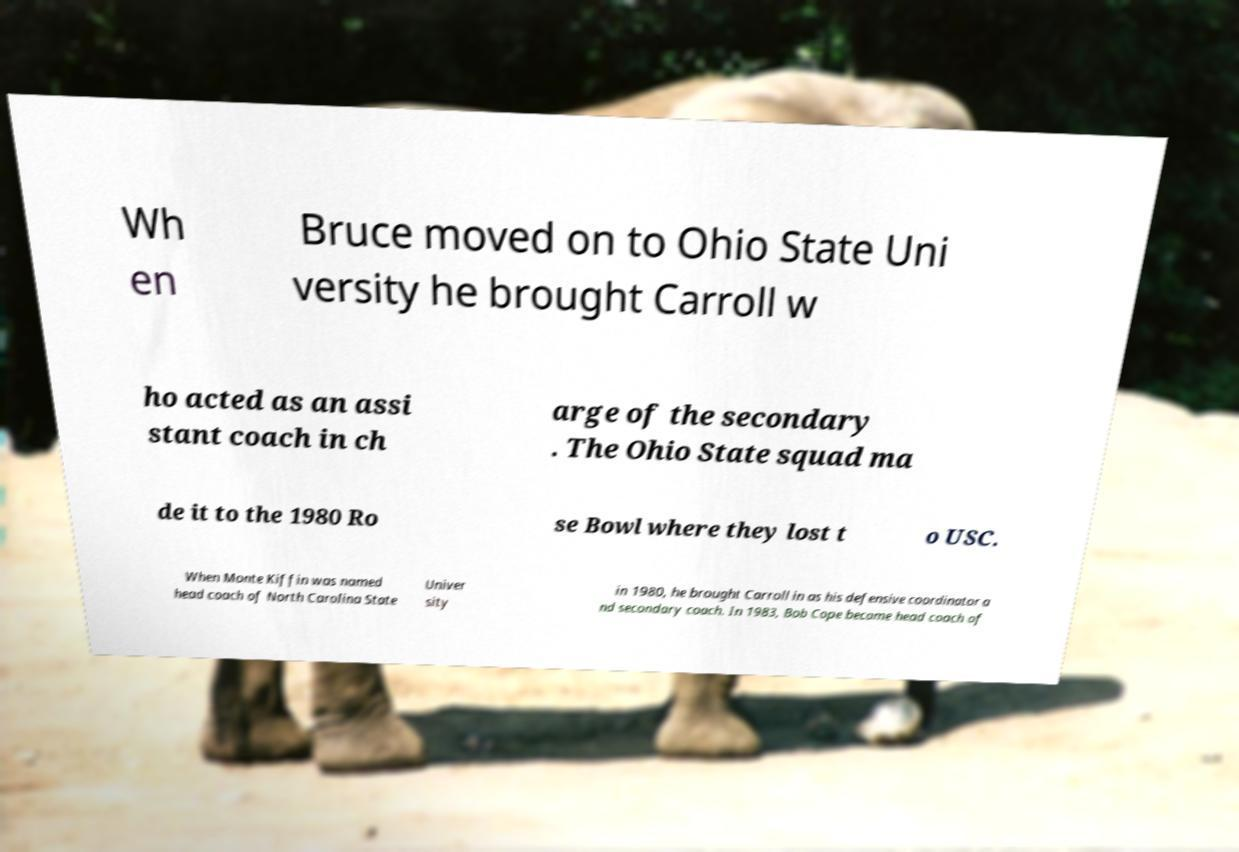Could you assist in decoding the text presented in this image and type it out clearly? Wh en Bruce moved on to Ohio State Uni versity he brought Carroll w ho acted as an assi stant coach in ch arge of the secondary . The Ohio State squad ma de it to the 1980 Ro se Bowl where they lost t o USC. When Monte Kiffin was named head coach of North Carolina State Univer sity in 1980, he brought Carroll in as his defensive coordinator a nd secondary coach. In 1983, Bob Cope became head coach of 